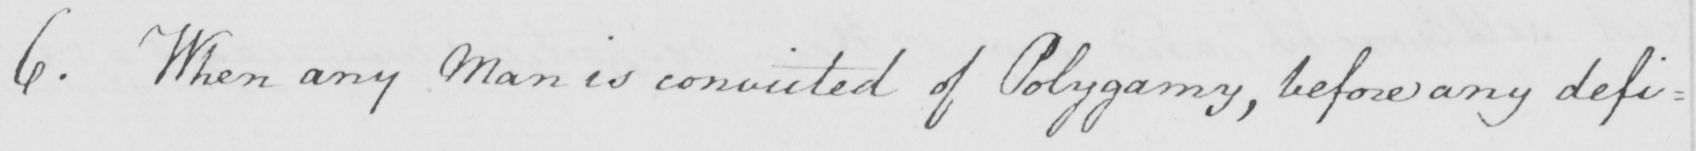Can you read and transcribe this handwriting? 6 . When any Man is convicted of Polygamy , before any defi= 